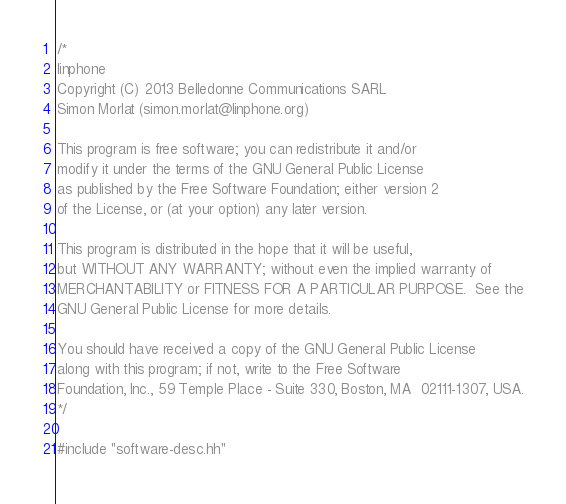Convert code to text. <code><loc_0><loc_0><loc_500><loc_500><_C++_>/*
linphone
Copyright (C) 2013 Belledonne Communications SARL
Simon Morlat (simon.morlat@linphone.org)

This program is free software; you can redistribute it and/or
modify it under the terms of the GNU General Public License
as published by the Free Software Foundation; either version 2
of the License, or (at your option) any later version.

This program is distributed in the hope that it will be useful,
but WITHOUT ANY WARRANTY; without even the implied warranty of
MERCHANTABILITY or FITNESS FOR A PARTICULAR PURPOSE.  See the
GNU General Public License for more details.

You should have received a copy of the GNU General Public License
along with this program; if not, write to the Free Software
Foundation, Inc., 59 Temple Place - Suite 330, Boston, MA  02111-1307, USA.
*/

#include "software-desc.hh"
</code> 